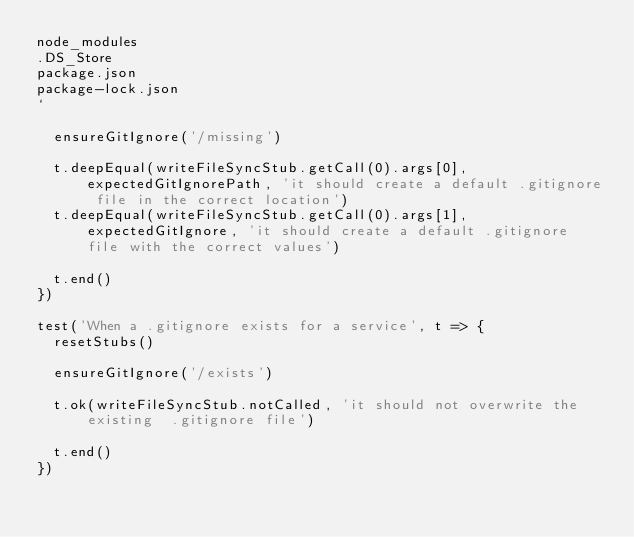<code> <loc_0><loc_0><loc_500><loc_500><_JavaScript_>node_modules
.DS_Store
package.json
package-lock.json
`

  ensureGitIgnore('/missing')

  t.deepEqual(writeFileSyncStub.getCall(0).args[0], expectedGitIgnorePath, 'it should create a default .gitignore file in the correct location')
  t.deepEqual(writeFileSyncStub.getCall(0).args[1], expectedGitIgnore, 'it should create a default .gitignore file with the correct values')

  t.end()
})

test('When a .gitignore exists for a service', t => {
  resetStubs()

  ensureGitIgnore('/exists')

  t.ok(writeFileSyncStub.notCalled, 'it should not overwrite the existing  .gitignore file')

  t.end()
})
</code> 